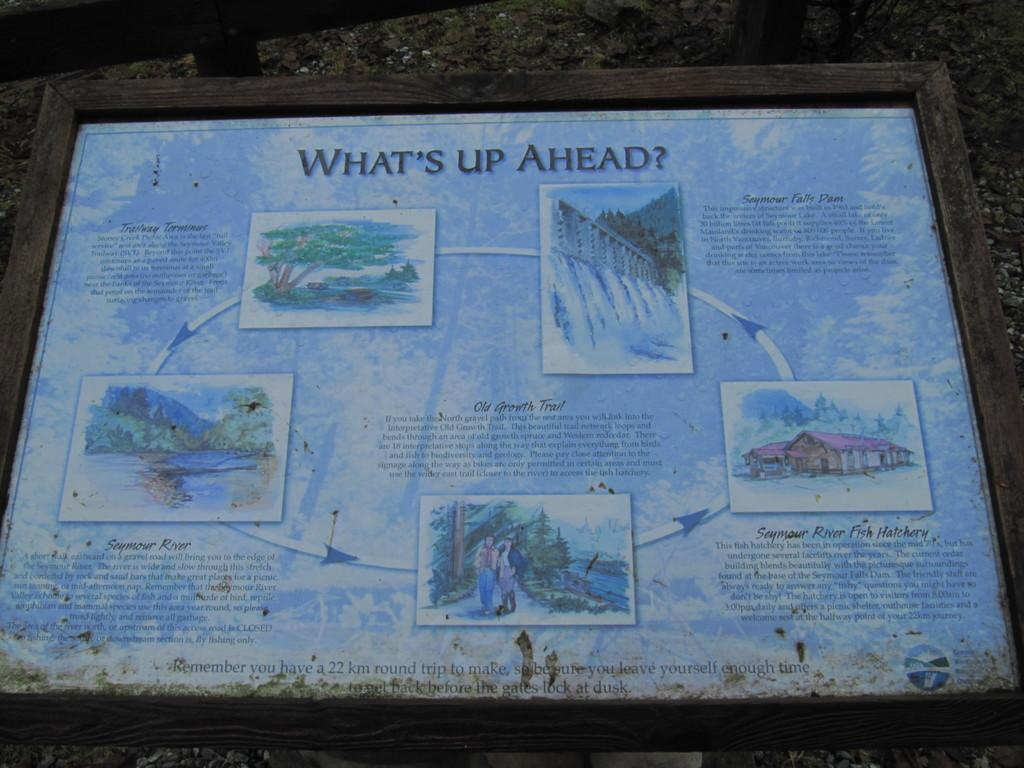What is the main subject of the image? The main subject of the image is a frame. What is featured on the frame? There is text and images on the frame. How does the guide help the frame in the image? There is no guide present in the image, and therefore no such assistance can be observed. What type of rub is applied to the images on the frame? There is no rub applied to the images on the frame in the image. 